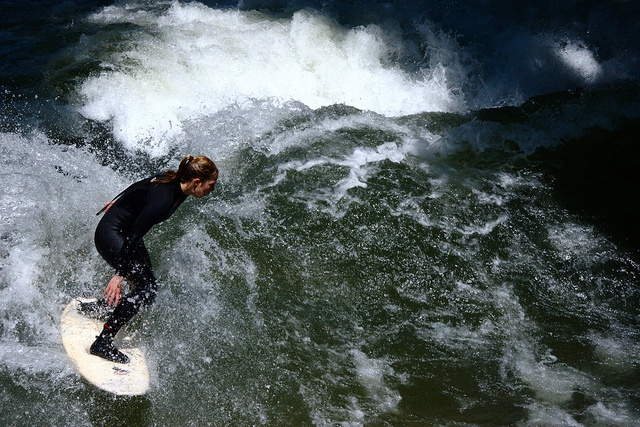Describe the objects in this image and their specific colors. I can see people in black, ivory, darkgray, and gray tones and surfboard in black, ivory, gray, and darkgray tones in this image. 